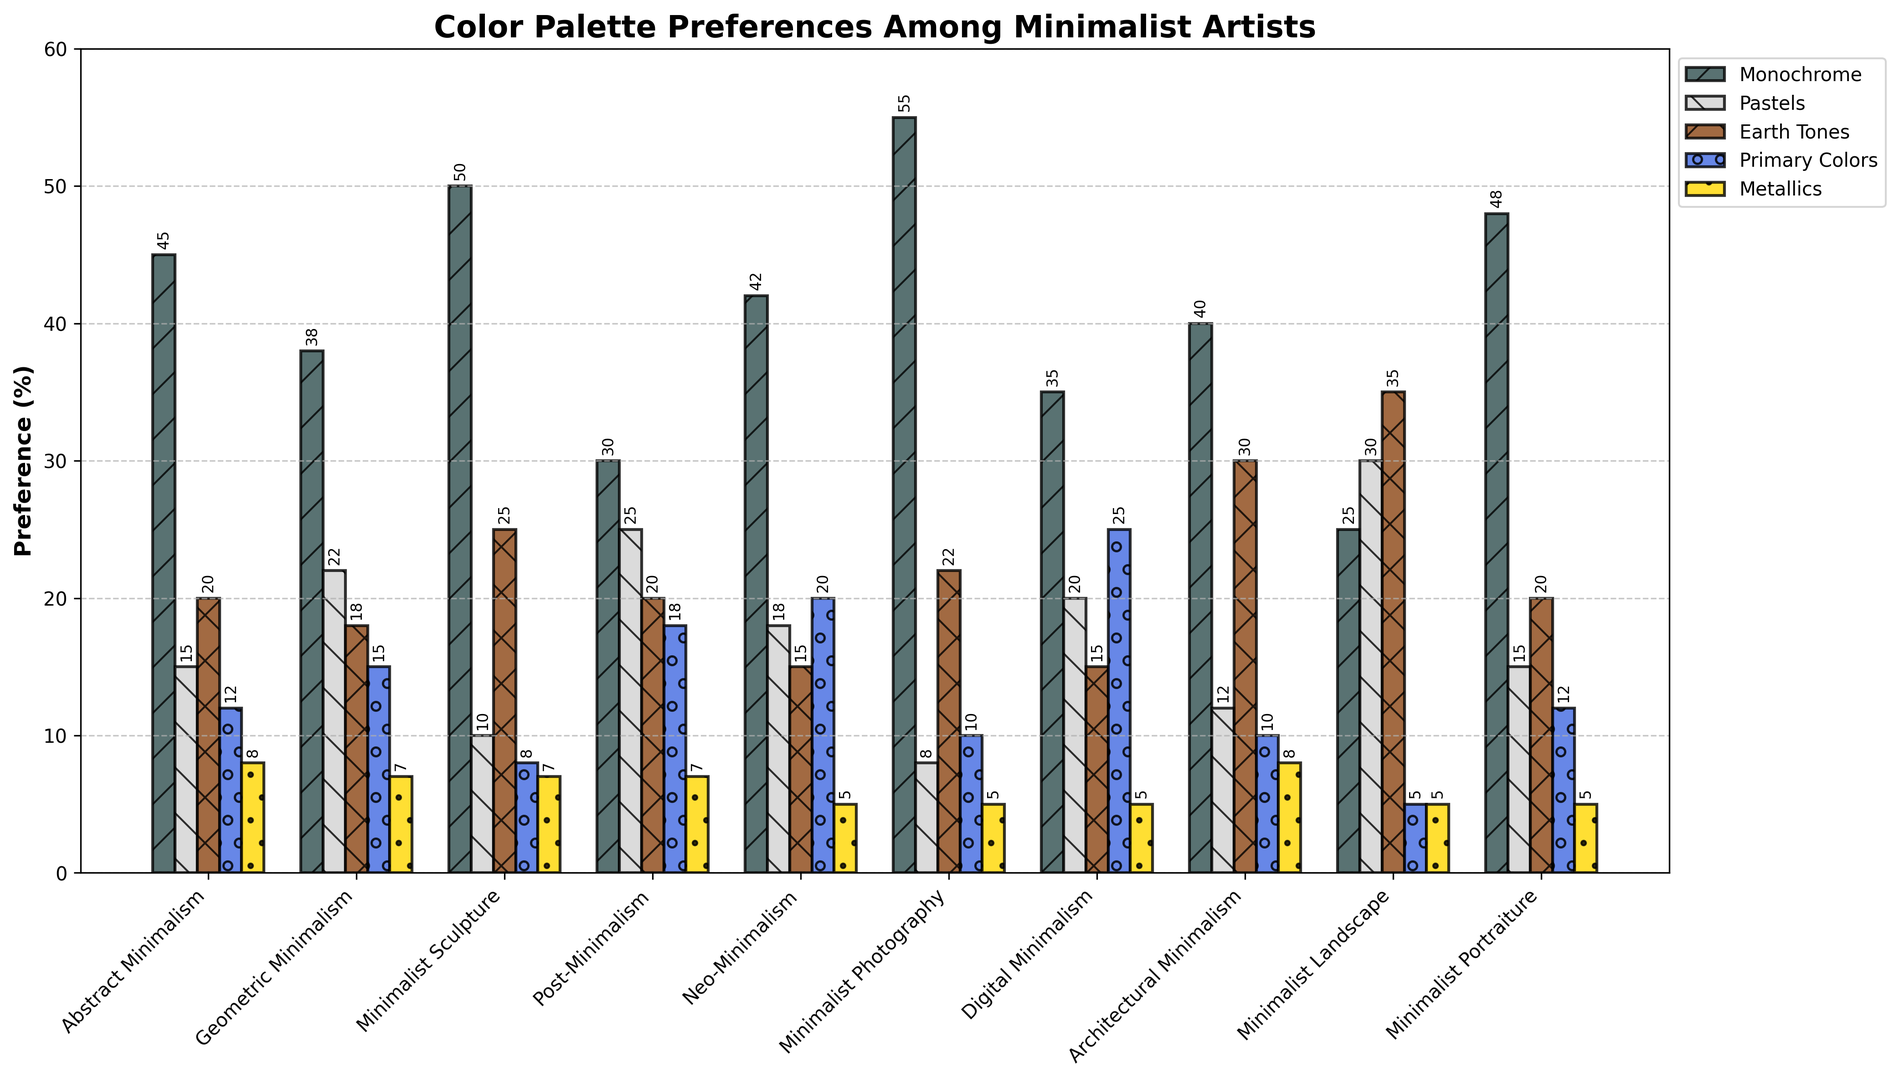What movement has the highest preference for Monochrome? To find the highest preference for Monochrome, we compare the heights of the Monochrome bars across all art movements. Minimalist Photography has the highest Monochrome preference at 55%.
Answer: Minimalist Photography Which movement shows the least preference for Metallics? To determine the least preference for Metallics, we compare the heights of the Metallics bars across all movements. Neo-Minimalism, Minimalist Photography, Digital Minimalism, Minimalist Landscape, and Minimalist Portraiture each have the lowest value at 5%.
Answer: Neo-Minimalism, Minimalist Photography, Digital Minimalism, Minimalist Landscape, Minimalist Portraiture What is the total percentage preference for Pastels across all movements? Summing up the values for Pastels from each movement: 15 + 22 + 10 + 25 + 18 + 8 + 20 + 12 + 30 + 15 = 175%.
Answer: 175% Which movements prefer Primary Colors more than Earth Tones? Comparing the heights of the Primary Colors and Earth Tones bars for each movement: Post-Minimalism and Digital Minimalism have higher values for Primary Colors than Earth Tones.
Answer: Post-Minimalism, Digital Minimalism What is the average preference for Earth Tones in Minimalist Sculpture and Architectural Minimalism? Adding the Earth Tones preferences for both movements and dividing by 2: (25 + 30) / 2 = 27.5%.
Answer: 27.5% Which color palette has the smallest range of preferences across movements? To determine the range, subtract the smallest value from the largest value for each color palette. The ranges are: Monochrome (30), Pastels (22), Earth Tones (20), Primary Colors (20), Metallics (3). Metallics have the smallest range of 3%.
Answer: Metallics What is the difference in Monochrome preference between Abstract and Geometric Minimalism? Subtracting the Monochrome value for Geometric Minimalism from Abstract Minimalism: 45 - 38 = 7%.
Answer: 7% How many movements have less than 20% preference for Pastels? Counting the movements with Pastels preference below 20%: Abstract Minimalism, Minimalist Sculpture, Minimalist Photography, Architectural Minimalism, and Minimalist Portraiture have values less than 20%. Therefore, there are 5 such movements.
Answer: 5 In which movement is the combination of Monochrome and Primary Colors exactly 60%? Adding the values of Monochrome and Primary Colors for each movement to see which sum to 60%: Minimalist Portraiture has 48 + 12 = 60%.
Answer: Minimalist Portraiture 